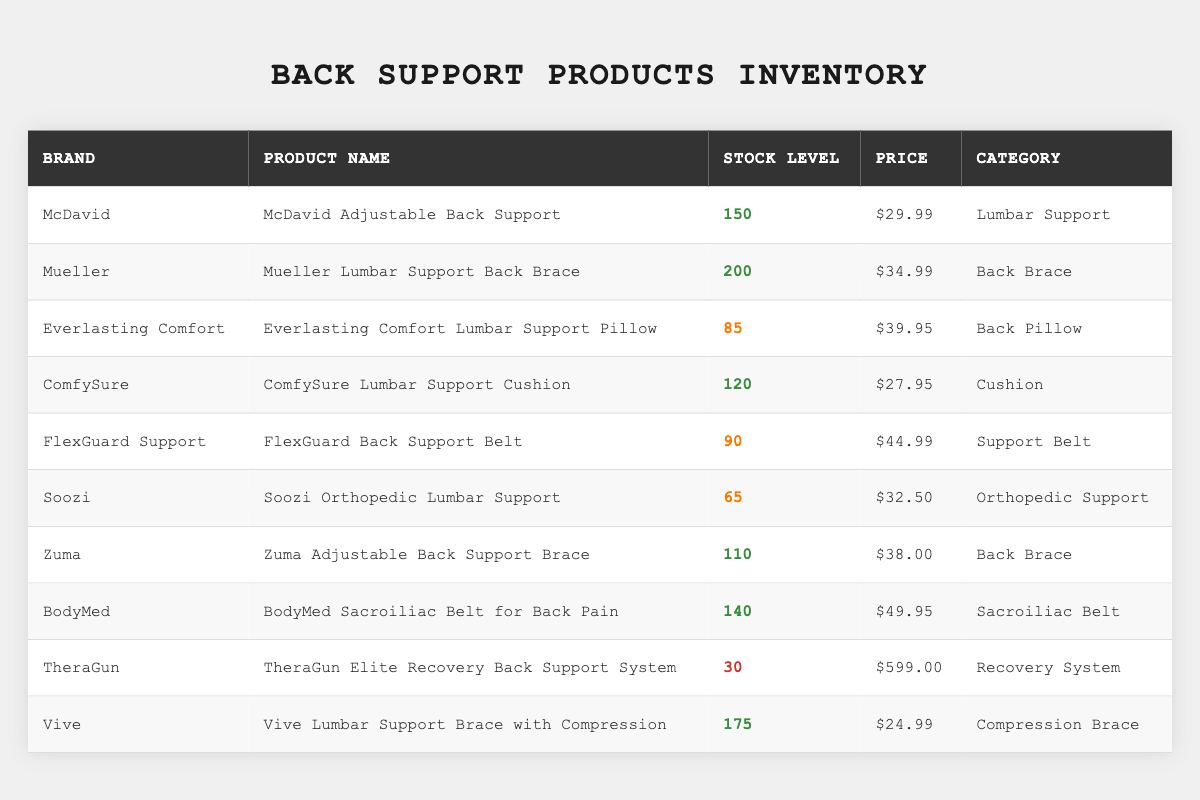What is the stock level of the McDavid Adjustable Back Support? According to the table, the stock level for the McDavid Adjustable Back Support is clearly listed as 150.
Answer: 150 Which brand offers the highest stock level of back support products? By comparing the stock levels, Mueller has the highest stock level at 200.
Answer: Mueller What is the price of the Vive Lumbar Support Brace with Compression? The table indicates that the price for the Vive Lumbar Support Brace with Compression is $24.99.
Answer: $24.99 How much stock is available for the TheraGun Elite Recovery Back Support System? The TheraGun Elite Recovery Back Support System shows a stock level of 30 in the inventory table.
Answer: 30 What is the total stock level of all products categorized as "Back Brace"? The stock levels for Back Braces are 200 (Mueller) + 110 (Zuma), which totals 310.
Answer: 310 Which product has the lowest stock level, and what is that stock level? The TheraGun Elite Recovery Back Support System has the lowest stock level of 30.
Answer: 30 Do any of the products have a stock level below 50? Yes, the Soozi Orthopedic Lumbar Support has a stock level of 65, which is below 50.
Answer: No How many products have a stock level greater than 100? The products with stock levels over 100 are McDavid (150), Mueller (200), ComfySure (120), Zuma (110), BodyMed (140), and Vive (175), totaling 6 products.
Answer: 6 What is the average price of all back support products? The total prices of all products are $29.99 + $34.99 + $39.95 + $27.95 + $44.99 + $32.50 + $38.00 + $49.95 + $599.00 + $24.99 = $ 919.32. There are 10 products, so the average price is $919.32 / 10 = $91.93.
Answer: $91.93 Which product has the highest price, and what is that price? The TheraGun Elite Recovery Back Support System has the highest price of $599.00.
Answer: $599.00 